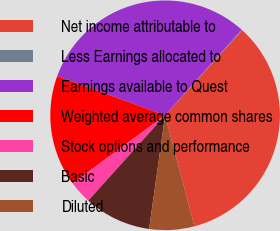Convert chart to OTSL. <chart><loc_0><loc_0><loc_500><loc_500><pie_chart><fcel>Net income attributable to<fcel>Less Earnings allocated to<fcel>Earnings available to Quest<fcel>Weighted average common shares<fcel>Stock options and performance<fcel>Basic<fcel>Diluted<nl><fcel>34.17%<fcel>0.12%<fcel>31.06%<fcel>15.65%<fcel>3.23%<fcel>9.44%<fcel>6.33%<nl></chart> 